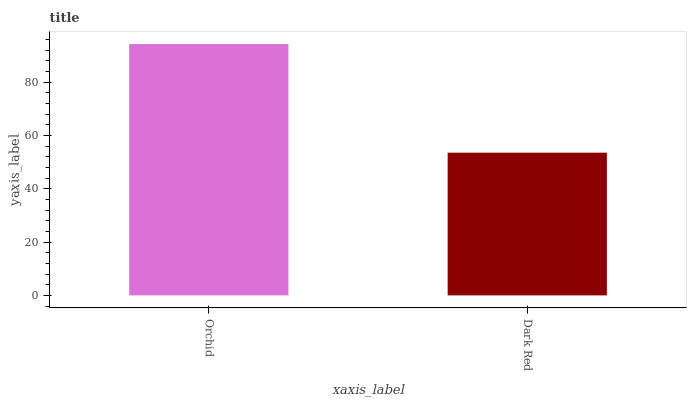Is Dark Red the minimum?
Answer yes or no. Yes. Is Orchid the maximum?
Answer yes or no. Yes. Is Dark Red the maximum?
Answer yes or no. No. Is Orchid greater than Dark Red?
Answer yes or no. Yes. Is Dark Red less than Orchid?
Answer yes or no. Yes. Is Dark Red greater than Orchid?
Answer yes or no. No. Is Orchid less than Dark Red?
Answer yes or no. No. Is Orchid the high median?
Answer yes or no. Yes. Is Dark Red the low median?
Answer yes or no. Yes. Is Dark Red the high median?
Answer yes or no. No. Is Orchid the low median?
Answer yes or no. No. 